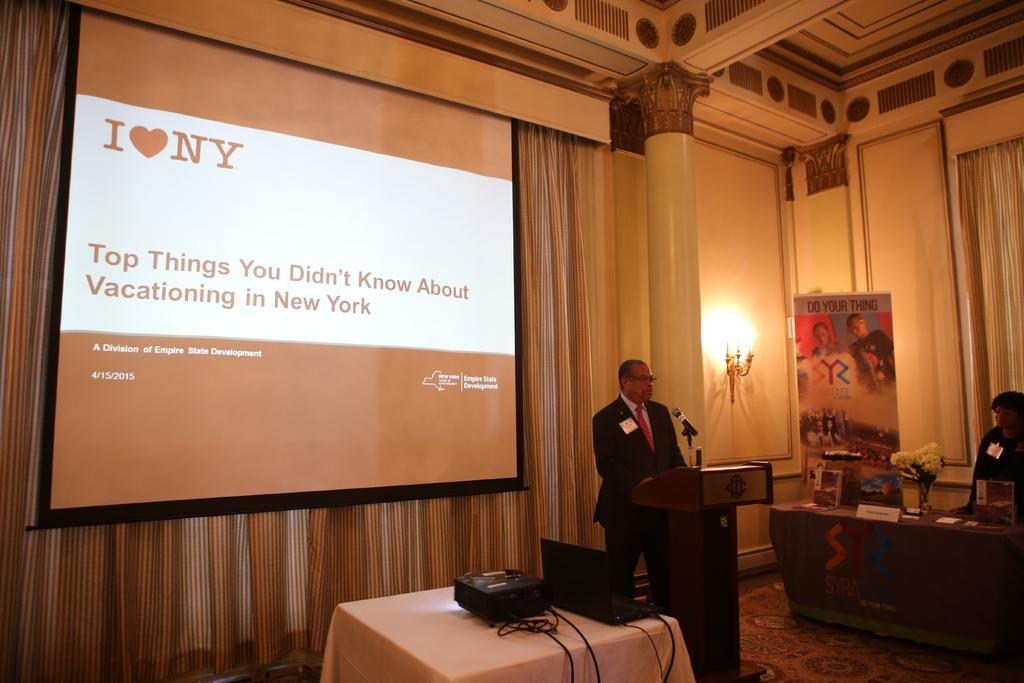Can you describe this image briefly? In this image, we can see a man standing and there is a microphone, there is a table covered with white color cloth, there is a projector and a black color laptop on the table, we can see a power point presentation. 